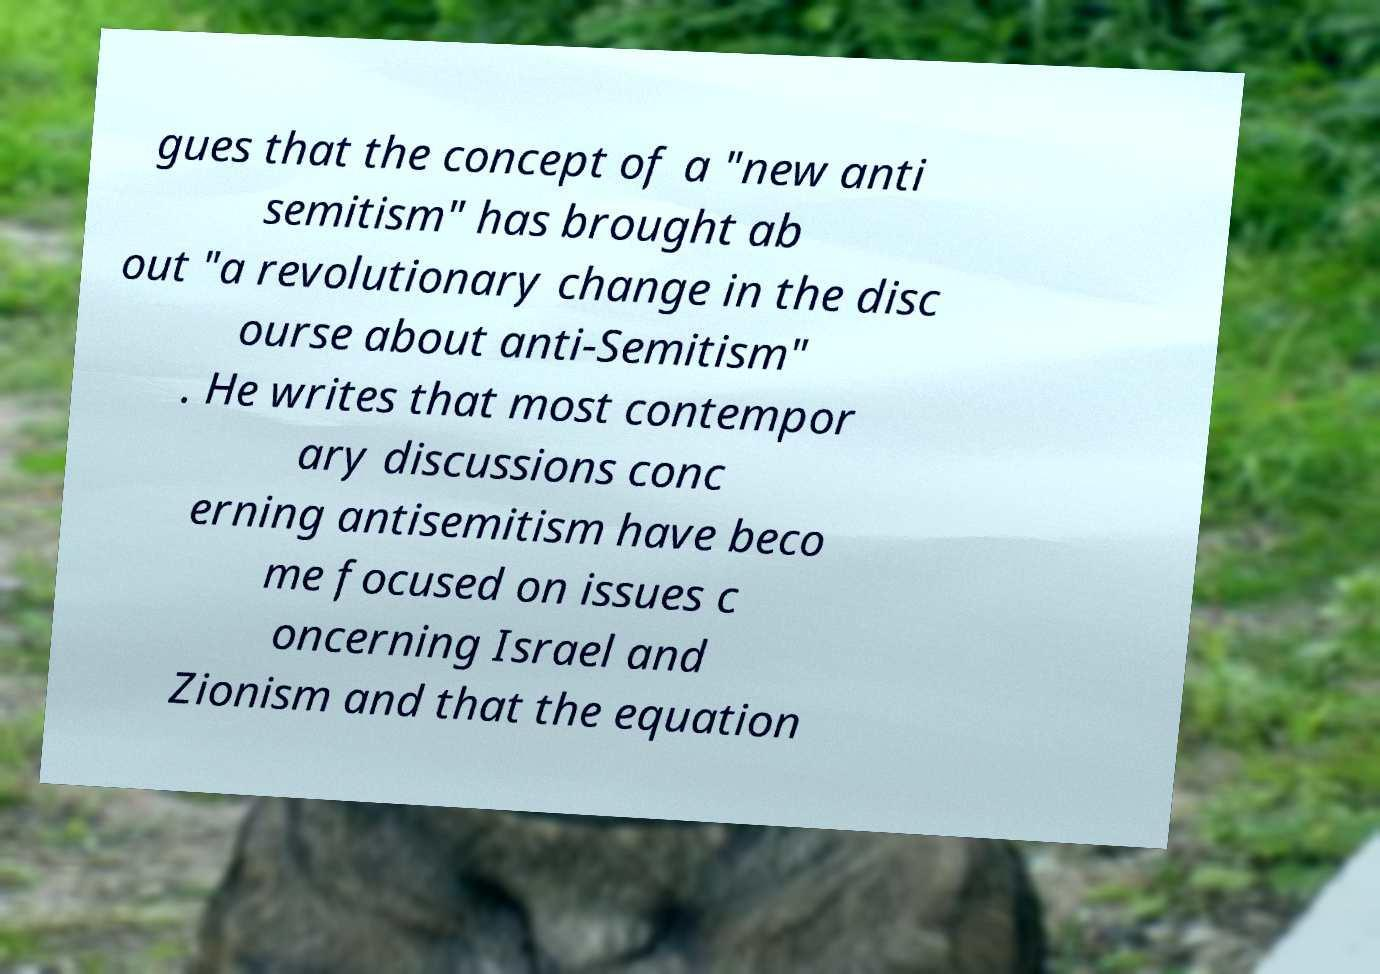Could you assist in decoding the text presented in this image and type it out clearly? gues that the concept of a "new anti semitism" has brought ab out "a revolutionary change in the disc ourse about anti-Semitism" . He writes that most contempor ary discussions conc erning antisemitism have beco me focused on issues c oncerning Israel and Zionism and that the equation 